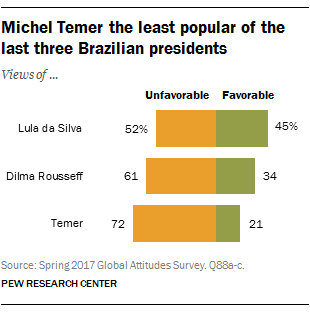Point out several critical features in this image. The difference between the highest yellow bar and the lowest green bar is 51. What is the lowest value of the green bar? 21. 